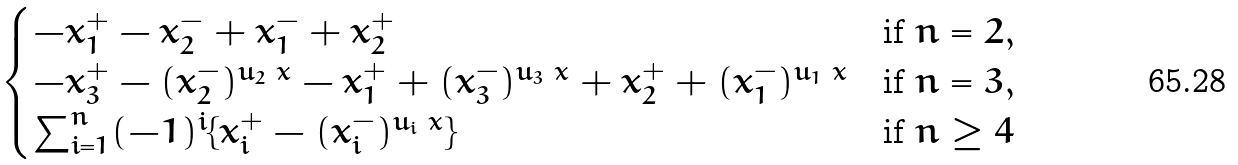Convert formula to latex. <formula><loc_0><loc_0><loc_500><loc_500>\begin{cases} - x ^ { + } _ { 1 } - x ^ { - } _ { 2 } + x ^ { - } _ { 1 } + x ^ { + } _ { 2 } & \text {if } n = 2 , \\ - x ^ { + } _ { 3 } - ( x ^ { - } _ { 2 } ) ^ { u _ { 2 } \ x } - x ^ { + } _ { 1 } + ( x ^ { - } _ { 3 } ) ^ { u _ { 3 } \ x } + x ^ { + } _ { 2 } + ( x ^ { - } _ { 1 } ) ^ { u _ { 1 } \ x } & \text {if } n = 3 , \\ \sum _ { i = 1 } ^ { n } ( - 1 ) ^ { i } \{ x ^ { + } _ { i } - ( x ^ { - } _ { i } ) ^ { u _ { i } \ x } \} & \text {if } n \geq 4 \end{cases}</formula> 